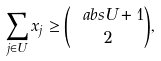<formula> <loc_0><loc_0><loc_500><loc_500>\sum _ { j \in U } x _ { j } \geq \binom { \ a b s U + 1 } 2 ,</formula> 